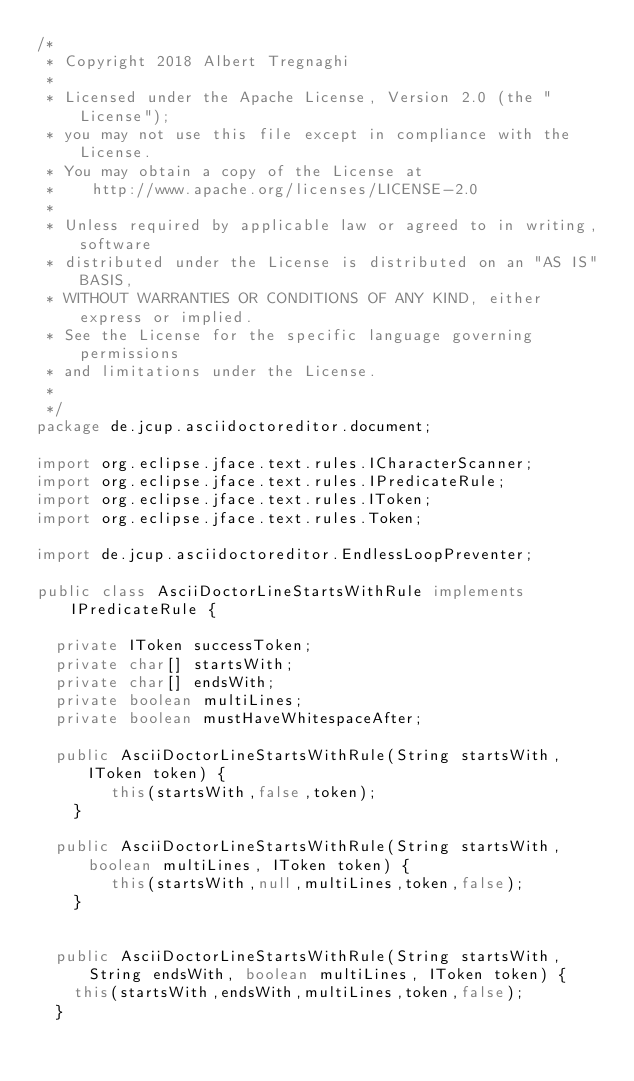Convert code to text. <code><loc_0><loc_0><loc_500><loc_500><_Java_>/*
 * Copyright 2018 Albert Tregnaghi
 *
 * Licensed under the Apache License, Version 2.0 (the "License");
 * you may not use this file except in compliance with the License.
 * You may obtain a copy of the License at
 *		http://www.apache.org/licenses/LICENSE-2.0
 *
 * Unless required by applicable law or agreed to in writing, software
 * distributed under the License is distributed on an "AS IS" BASIS,
 * WITHOUT WARRANTIES OR CONDITIONS OF ANY KIND, either express or implied.
 * See the License for the specific language governing permissions
 * and limitations under the License.
 *
 */
package de.jcup.asciidoctoreditor.document;

import org.eclipse.jface.text.rules.ICharacterScanner;
import org.eclipse.jface.text.rules.IPredicateRule;
import org.eclipse.jface.text.rules.IToken;
import org.eclipse.jface.text.rules.Token;

import de.jcup.asciidoctoreditor.EndlessLoopPreventer;

public class AsciiDoctorLineStartsWithRule implements IPredicateRule {

	private IToken successToken;
	private char[] startsWith;
	private char[] endsWith;
	private boolean multiLines;
	private boolean mustHaveWhitespaceAfter;
	
	public AsciiDoctorLineStartsWithRule(String startsWith, IToken token) {
        this(startsWith,false,token);
    }
	
	public AsciiDoctorLineStartsWithRule(String startsWith, boolean multiLines, IToken token) {
        this(startsWith,null,multiLines,token,false);
    }
    
	
	public AsciiDoctorLineStartsWithRule(String startsWith, String endsWith, boolean multiLines, IToken token) {
		this(startsWith,endsWith,multiLines,token,false);
	}
	</code> 